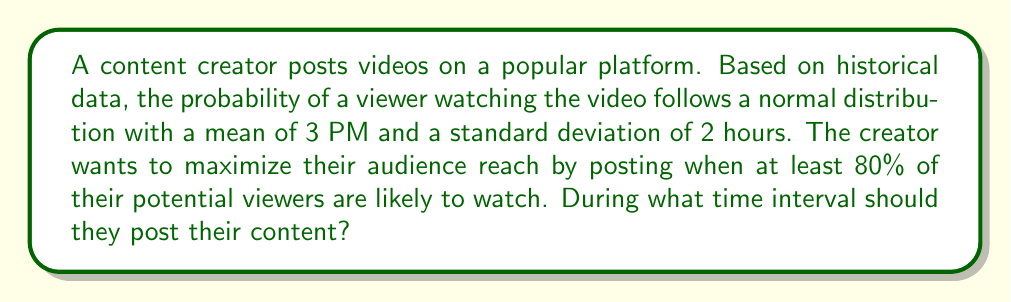Teach me how to tackle this problem. To solve this problem, we need to use the properties of the normal distribution and find the interval that contains 80% of the area under the curve, centered around the mean.

1. The mean (μ) is 3 PM, and the standard deviation (σ) is 2 hours.

2. We want to find the z-score that corresponds to 80% of the area under the normal curve. Since we want this centered around the mean, we're looking for 40% on each side.

3. Using a z-table or calculator, we find that a z-score of approximately ±1.28 corresponds to 40% of the area on each side of the mean.

4. We can convert this z-score back to hours using the formula:
   $$ x = \mu + z\sigma $$

5. For the lower bound:
   $$ x_{lower} = 3:00\text{ PM} + (-1.28 \times 2\text{ hours}) = 3:00\text{ PM} - 2.56\text{ hours} \approx 12:26\text{ PM} $$

6. For the upper bound:
   $$ x_{upper} = 3:00\text{ PM} + (1.28 \times 2\text{ hours}) = 3:00\text{ PM} + 2.56\text{ hours} \approx 5:34\text{ PM} $$

Therefore, the optimal time interval for posting is between approximately 12:26 PM and 5:34 PM.
Answer: The content creator should post their content between 12:26 PM and 5:34 PM to reach at least 80% of their potential audience. 